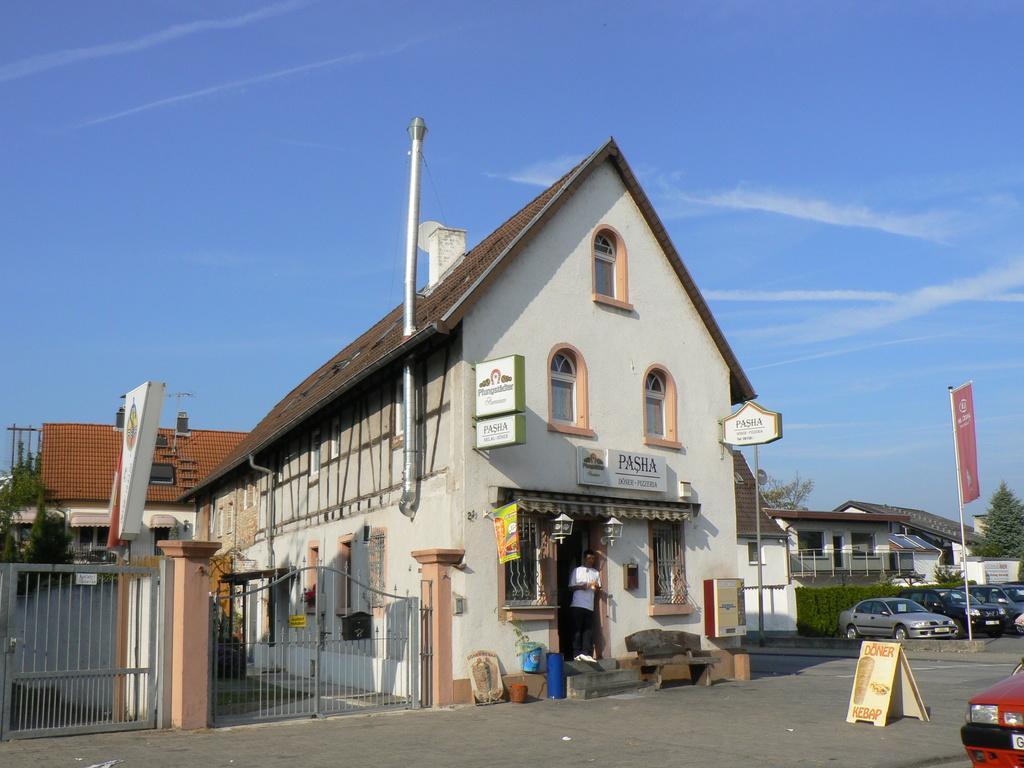How would you summarize this image in a sentence or two? In this image we can see a house with roof, pole, pipes, windows and a gate. A person standing near the door. On the right side we can see a board, buildings, trees, flag to a pole and some cars parked aside. On the left side we can see a house with gate and trees, and the sky which looks cloudy. 